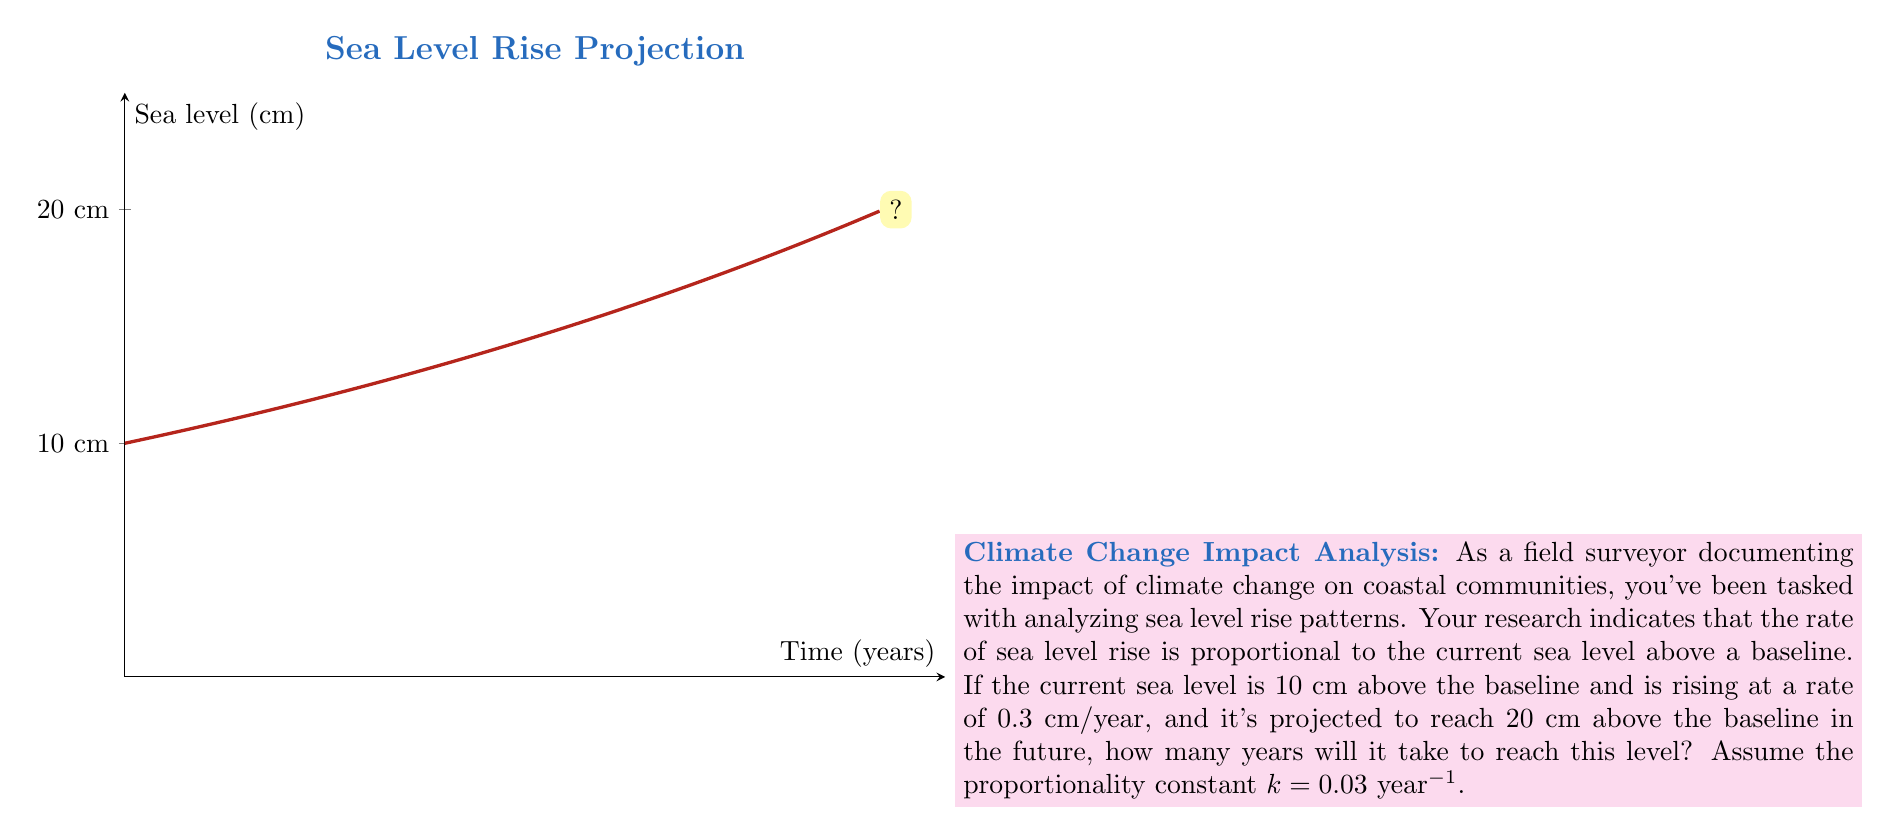Provide a solution to this math problem. Let's approach this step-by-step using an exponential differential equation:

1) Let $y(t)$ be the sea level above the baseline at time $t$ in years.

2) The rate of change is proportional to the current level:
   $$\frac{dy}{dt} = ky$$
   where $k = 0.03$ year$^{-1}$

3) This differential equation has the general solution:
   $$y(t) = Ce^{kt}$$
   where $C$ is a constant determined by initial conditions.

4) At $t = 0$, $y(0) = 10$ cm. So:
   $$10 = Ce^{0} = C$$

5) Therefore, our specific solution is:
   $$y(t) = 10e^{0.03t}$$

6) We want to find $t$ when $y(t) = 20$ cm:
   $$20 = 10e^{0.03t}$$

7) Dividing both sides by 10:
   $$2 = e^{0.03t}$$

8) Taking the natural logarithm of both sides:
   $$\ln(2) = 0.03t$$

9) Solving for $t$:
   $$t = \frac{\ln(2)}{0.03} \approx 23.10$$

Therefore, it will take approximately 23.10 years for the sea level to rise from 10 cm to 20 cm above the baseline.
Answer: 23.10 years 